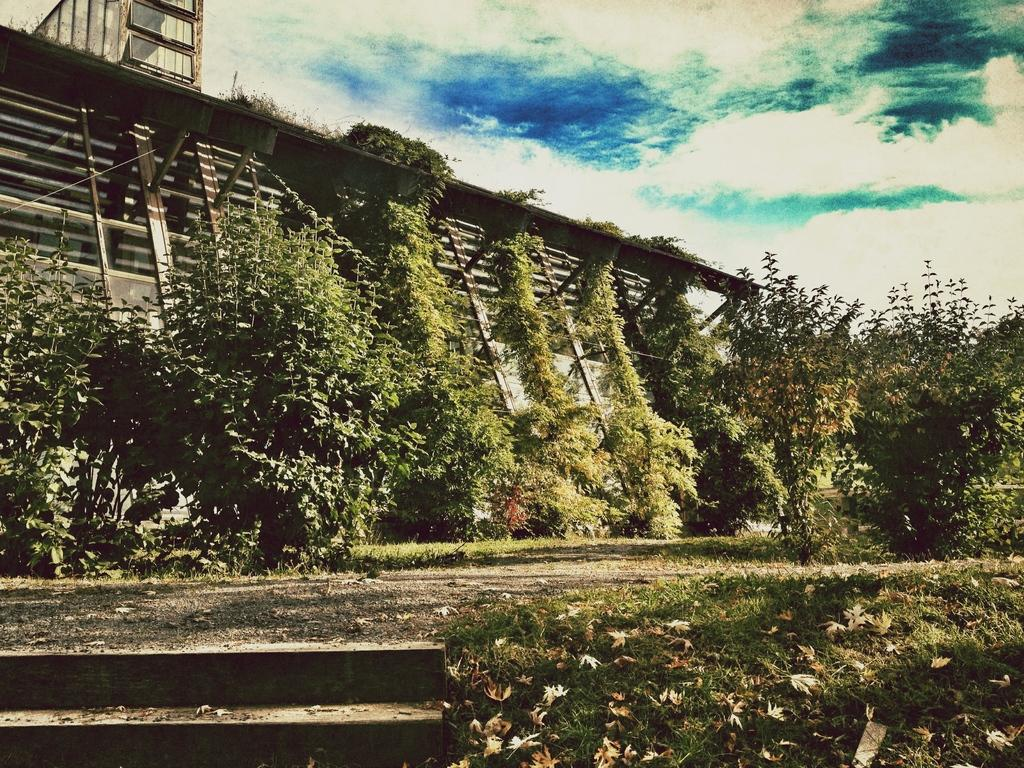What type of living organisms can be seen in the image? Plants can be seen in the image. What color are the plants in the image? The plants are green. What structure is visible in the background of the image? There is a shed in the background of the image. What colors are visible in the sky in the image? The sky is blue and white in color. Can you see any water in the image? There is no visible water in the image. What type of spacecraft is present in the image? There is no spacecraft present in the image; it features plants, a shed, and a blue and white sky. 